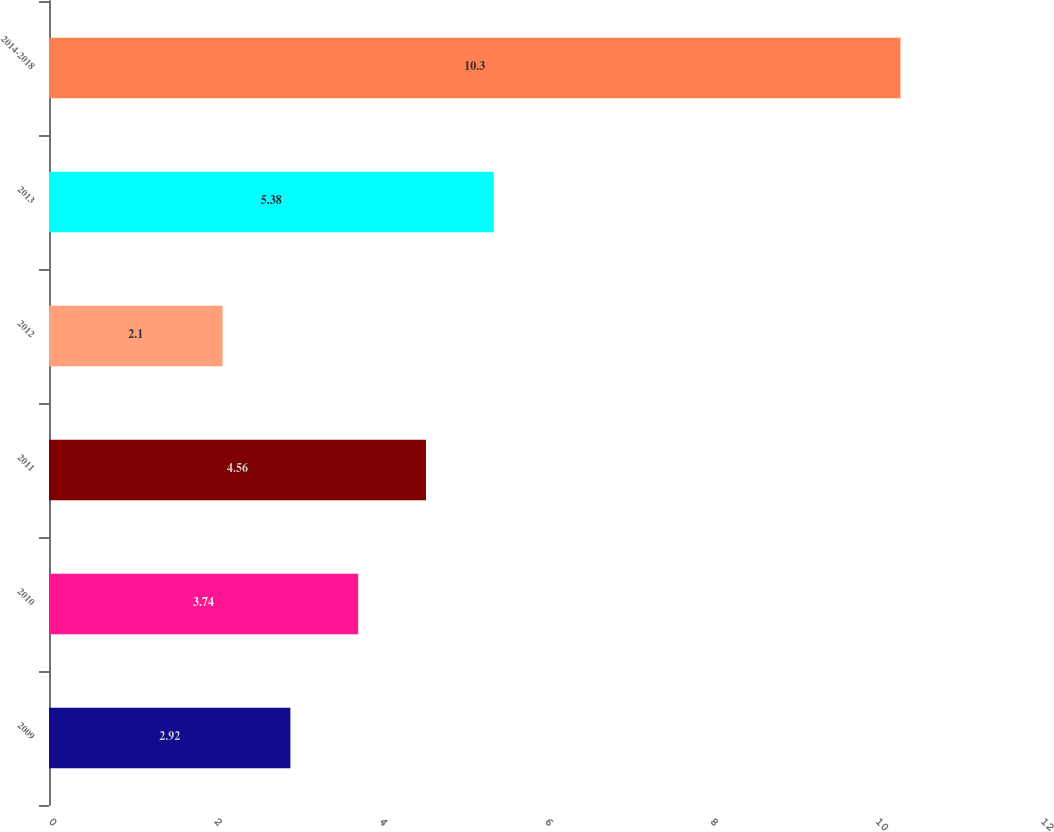<chart> <loc_0><loc_0><loc_500><loc_500><bar_chart><fcel>2009<fcel>2010<fcel>2011<fcel>2012<fcel>2013<fcel>2014-2018<nl><fcel>2.92<fcel>3.74<fcel>4.56<fcel>2.1<fcel>5.38<fcel>10.3<nl></chart> 